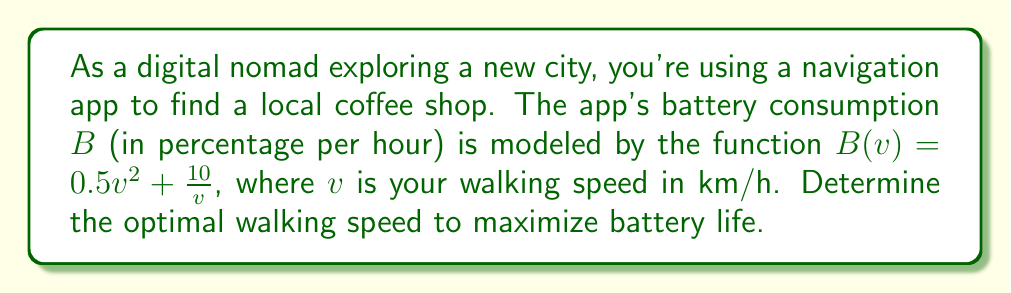Teach me how to tackle this problem. 1. To find the optimal walking speed, we need to minimize the battery consumption function $B(v)$.

2. The minimum of $B(v)$ occurs where its derivative equals zero. Let's find the derivative:

   $$B'(v) = (0.5v^2 + \frac{10}{v})'$$
   $$B'(v) = v - \frac{10}{v^2}$$

3. Set the derivative equal to zero and solve for $v$:

   $$v - \frac{10}{v^2} = 0$$
   $$v^3 - 10 = 0$$
   $$v^3 = 10$$
   $$v = \sqrt[3]{10}$$

4. To confirm this is a minimum, we can check the second derivative:

   $$B''(v) = 1 + \frac{20}{v^3}$$

   At $v = \sqrt[3]{10}$, $B''(v) > 0$, confirming a minimum.

5. Calculate the optimal speed:

   $$v = \sqrt[3]{10} \approx 2.154 \text{ km/h}$$
Answer: $\sqrt[3]{10} \approx 2.154 \text{ km/h}$ 